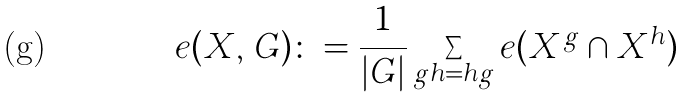<formula> <loc_0><loc_0><loc_500><loc_500>e ( X , \, G ) \colon = \frac { 1 } { | G | } \sum _ { g h = h g } e ( X ^ { g } \cap X ^ { h } )</formula> 